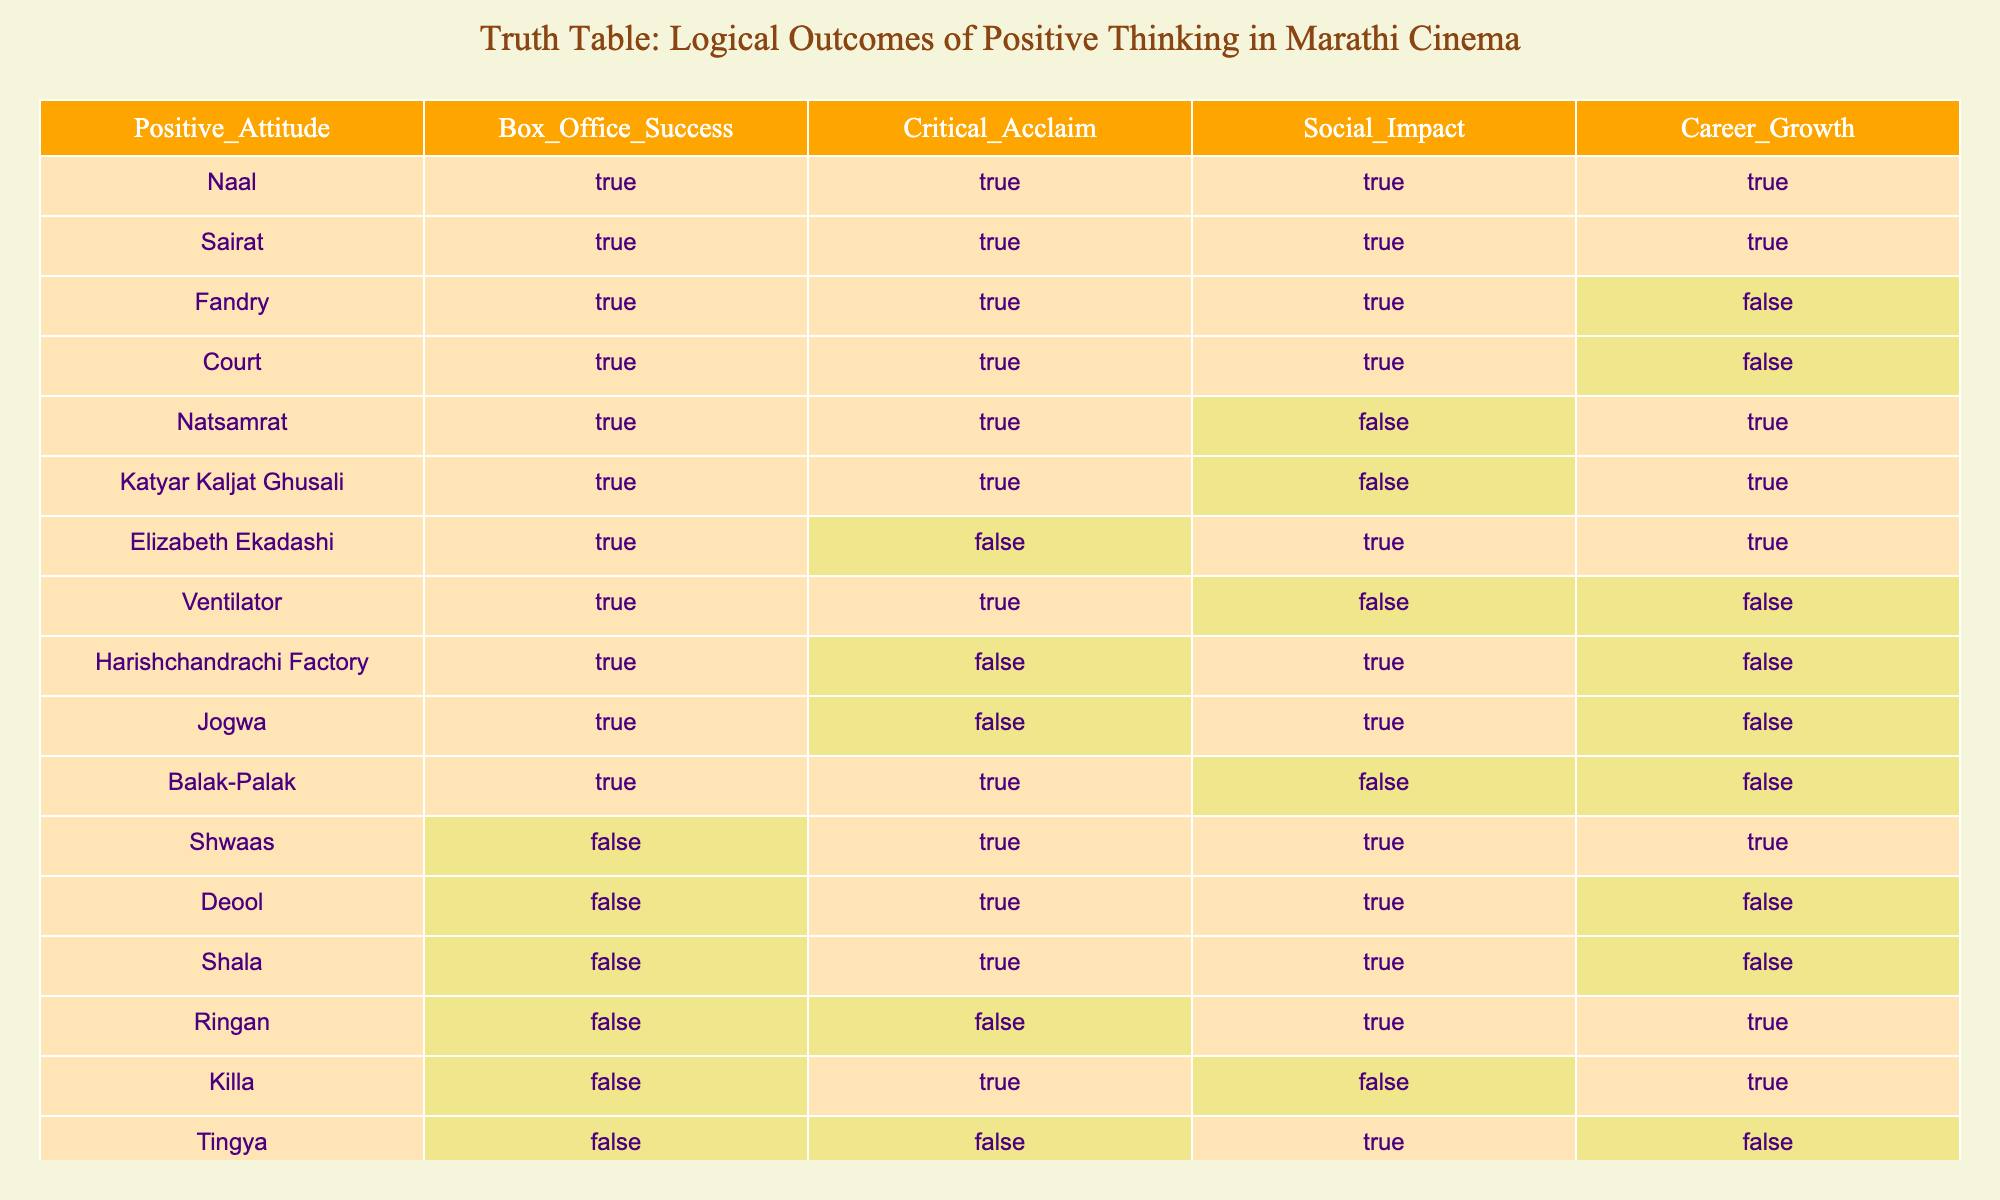What is the total number of films with a positive attitude that also achieved box office success? There are 9 films in the table that listed as having a positive attitude. Out of these films, Naal, Sairat, Fandry, Court, Natsamrat, Katyar Kaljat Ghusali, Balak-Palak, Ventilator, and Jogwa all achieved box office success. Thus, the total number is 9.
Answer: 9 How many films have both box office success and critical acclaim? By reviewing the data, we can see that the films Naal, Sairat, Fandry, Court, Natsamrat, Katyar Kaljat Ghusali, and Ventilator achieved both box office success and critical acclaim, totaling 7 films.
Answer: 7 Is there any film that has a positive attitude but did not achieve box office success? Yes, according to the table, Shwaas, Deool, Shala, Ringan, Killa, Tingya, and Vihir had no box office success but can be categorized as positive attitude films.
Answer: Yes What is the average social impact among the films that achieved box office success? After identifying the films that achieved box office success (Naal, Sairat, Fandry, Court, Natsamrat, Katyar Kaljat Ghusali, Balak-Palak, Jogwa), we see 6 films with the following social impact outcomes: TRUE for 4 films and FALSE for 4. The average is calculated by taking the count of TRUE outcomes divided by the total, so 4/8 = 0.5 or 50%.
Answer: 50% Are there any films with positive attitude and career growth that did not receive critical acclaim? Yes, films like Natsamrat and Katyar Kaljat Ghusali have a positive attitude, career growth, and did not receive critical acclaim.
Answer: Yes How many films received critical acclaim but did not achieve box office success? The films that have been critically acclaimed (TRUE in the critical acclaim column) but did not achieve box office success (FALSE in the box office success column) include Shwaas, Deool, Shala, and Balak-Palak. There are 4 such films.
Answer: 4 Which film had a positive attitude and achieved career growth but did not attain critical acclaim? The films Natsamrat and Katyar Kaljat Ghusali fit this category since they have a positive attitude and career growth, but both did not receive critical acclaim.
Answer: Natsamrat and Katyar Kaljat Ghusali What percentage of films with a positive attitude also achieved social impact? Out of the total of 9 films with a positive attitude, Naal, Sairat, Fandry, Court, Natsamrat, Katyar Kaljat Ghusali, Elizabeth Ekadashi, and Jogwa achieved social impact. Therefore, 7 out of 9 or approximately 77.78% achieved social impact.
Answer: 77.78% 